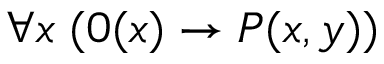<formula> <loc_0><loc_0><loc_500><loc_500>\forall x \, ( 0 ( x ) \rightarrow P ( x , y ) )</formula> 